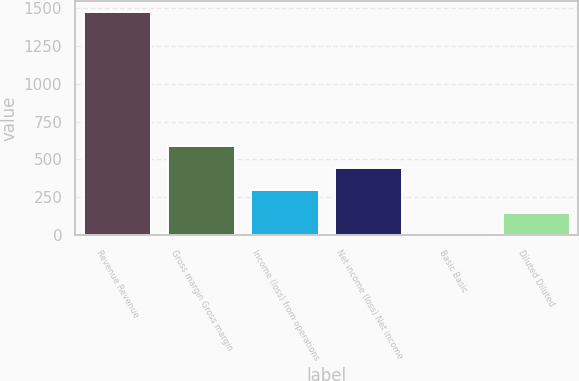Convert chart to OTSL. <chart><loc_0><loc_0><loc_500><loc_500><bar_chart><fcel>Revenue Revenue<fcel>Gross margin Gross margin<fcel>Income (loss) from operations<fcel>Net income (loss) Net income<fcel>Basic Basic<fcel>Diluted Diluted<nl><fcel>1473<fcel>589.49<fcel>294.99<fcel>442.24<fcel>0.49<fcel>147.74<nl></chart> 